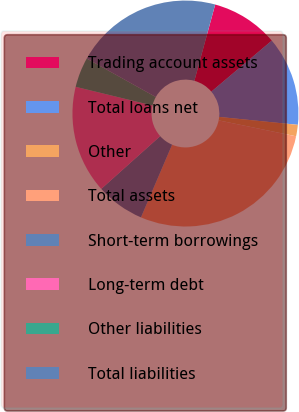<chart> <loc_0><loc_0><loc_500><loc_500><pie_chart><fcel>Trading account assets<fcel>Total loans net<fcel>Other<fcel>Total assets<fcel>Short-term borrowings<fcel>Long-term debt<fcel>Other liabilities<fcel>Total liabilities<nl><fcel>9.6%<fcel>12.76%<fcel>1.63%<fcel>28.21%<fcel>6.94%<fcel>15.42%<fcel>4.29%<fcel>21.15%<nl></chart> 